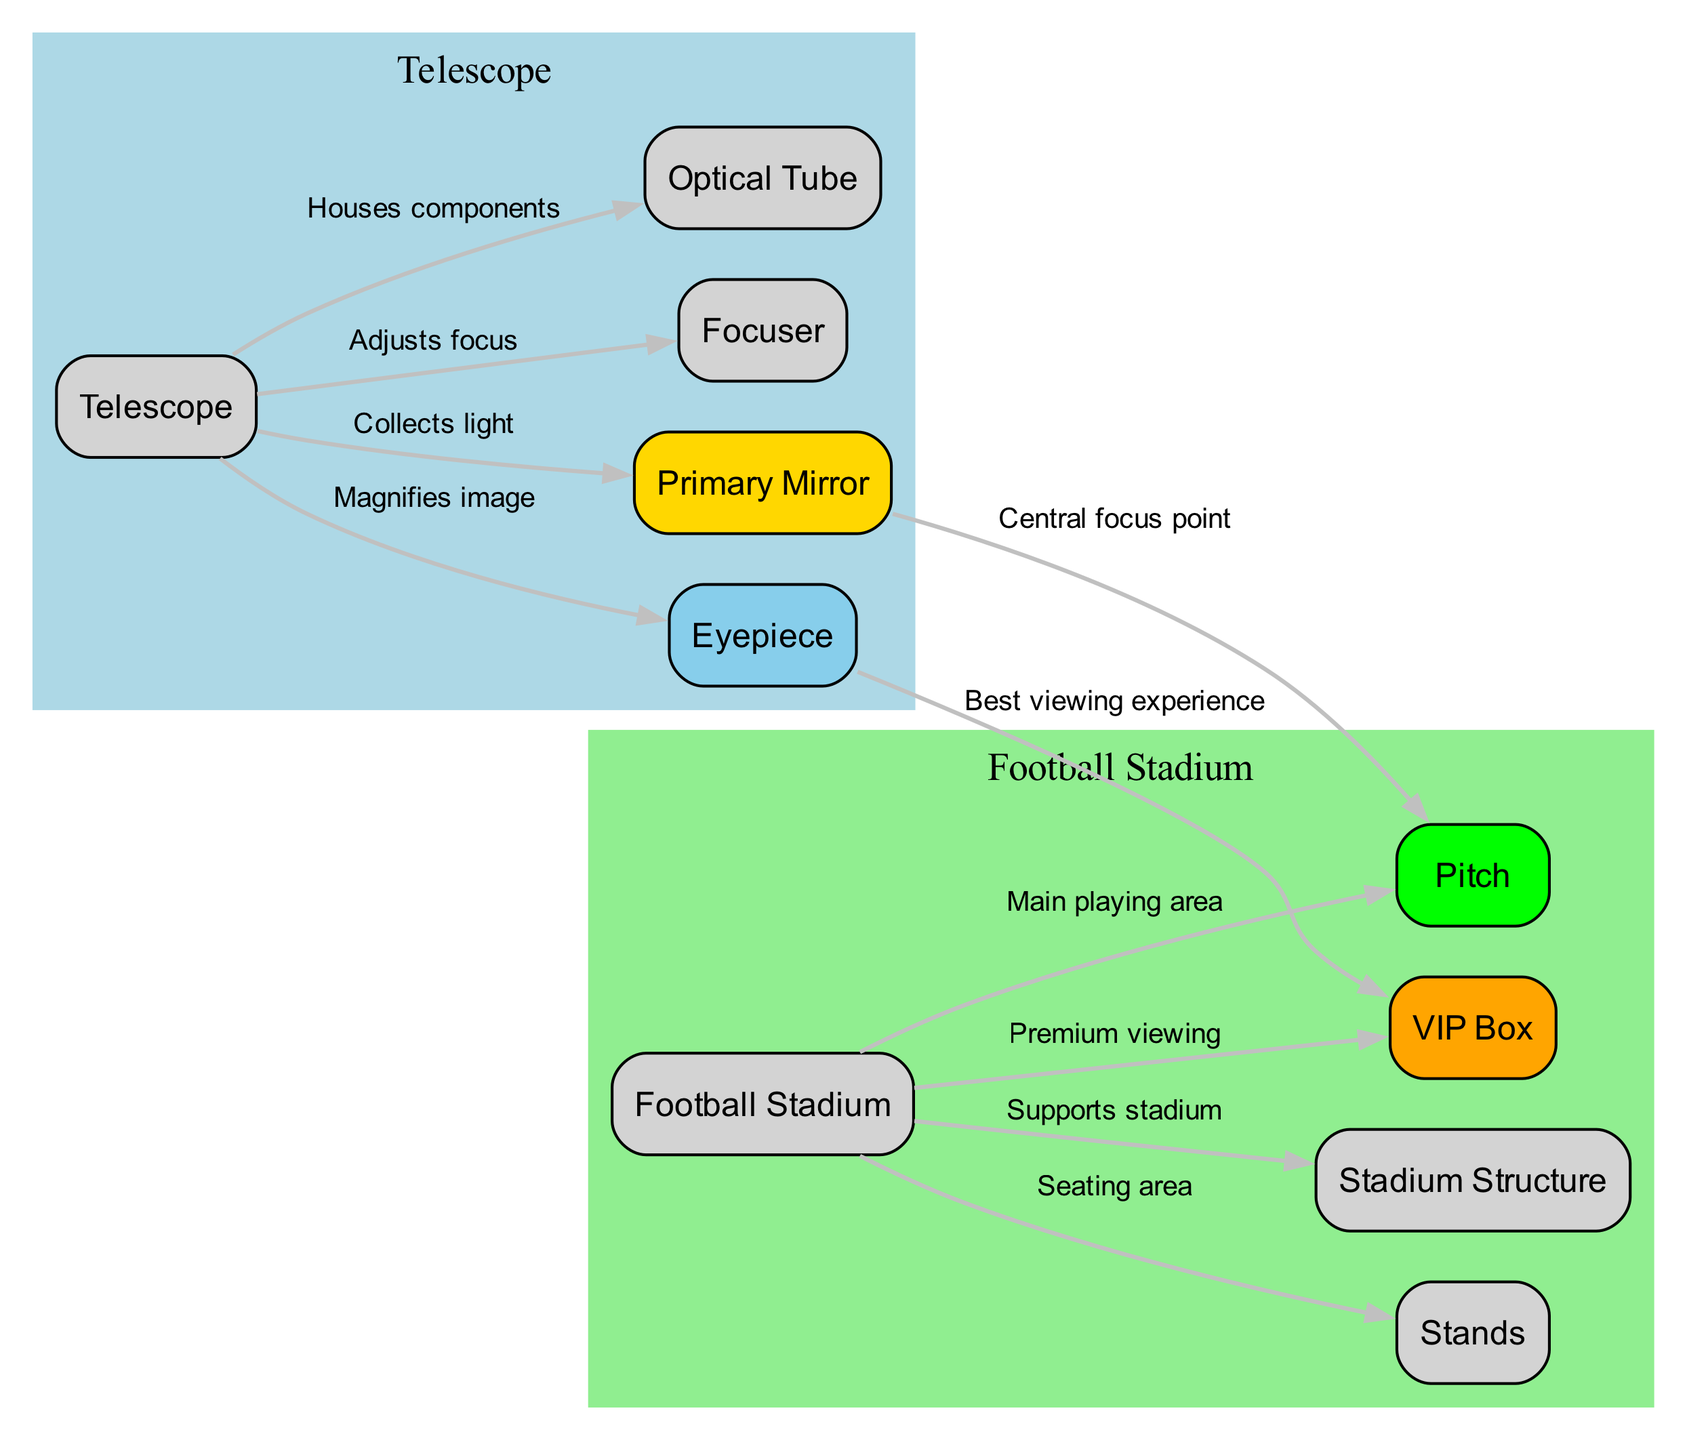What is the main function of the primary mirror in the telescope? The primary mirror collects light, which is essential for the functioning of the telescope and allows it to gather images of celestial objects.
Answer: Collects light How many nodes are present in the telescope section? The nodes related to the telescope are telescope, primary mirror, eyepiece, focuser, and tube, totaling 5 nodes in this section.
Answer: 5 Which component is associated with the best viewing experience in the telescope? The eyepiece is linked to providing the best viewing experience, serving as the lens through which the viewer observes the magnified image.
Answer: Eyepiece What is the relationship between the primary mirror and the pitch? The primary mirror serves as the central focus point in the telescope's light collection, while the pitch is a primary playing area in the stadium, indicating a parallel in focusing activities.
Answer: Central focus point What is the primary role of the stands in a football stadium? The stands serve as the seating area where spectators watch the game, analogous to how the tube houses the components of the telescope.
Answer: Seating area Which component adjusts the focus in the telescope? The focuser is responsible for adjusting the focus, allowing for clearer images.
Answer: Focuser How does the eyepiece relate to the VIP box in the stadium? The eyepiece magnifies the image for the viewer analogous to the VIP box providing premium viewing quality in the stadium.
Answer: Best viewing experience What supports the structure of the stadium? The stadium structure supports the entire stadium, ensuring its integrity and safety for spectators.
Answer: Supports stadium How many edges are present in the diagram? The edges represent the relationships between nodes in the diagram, totaling 8 edges connecting the components between the telescope and stadium.
Answer: 8 What does the tube house in the telescope? The tube houses the essential components of the telescope, protecting them and ensuring proper alignment.
Answer: Houses components 